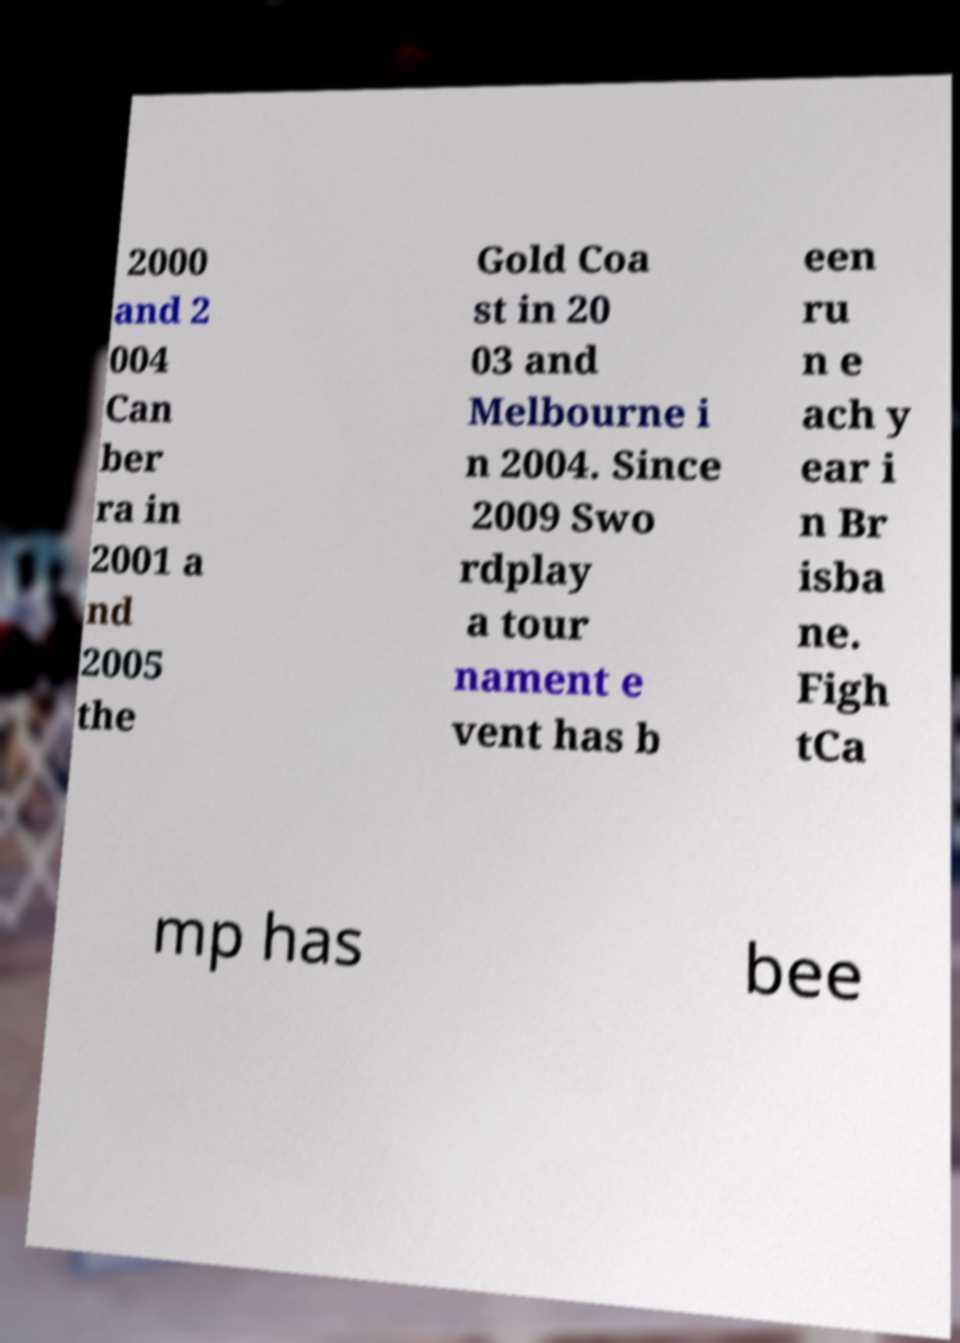There's text embedded in this image that I need extracted. Can you transcribe it verbatim? 2000 and 2 004 Can ber ra in 2001 a nd 2005 the Gold Coa st in 20 03 and Melbourne i n 2004. Since 2009 Swo rdplay a tour nament e vent has b een ru n e ach y ear i n Br isba ne. Figh tCa mp has bee 